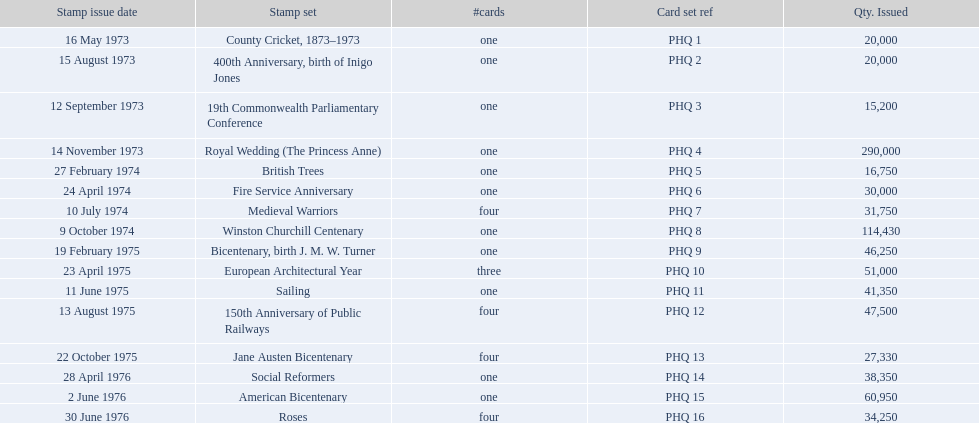Which year had the most stamps issued? 1973. Would you mind parsing the complete table? {'header': ['Stamp issue date', 'Stamp set', '#cards', 'Card set ref', 'Qty. Issued'], 'rows': [['16 May 1973', 'County Cricket, 1873–1973', 'one', 'PHQ 1', '20,000'], ['15 August 1973', '400th Anniversary, birth of Inigo Jones', 'one', 'PHQ 2', '20,000'], ['12 September 1973', '19th Commonwealth Parliamentary Conference', 'one', 'PHQ 3', '15,200'], ['14 November 1973', 'Royal Wedding (The Princess Anne)', 'one', 'PHQ 4', '290,000'], ['27 February 1974', 'British Trees', 'one', 'PHQ 5', '16,750'], ['24 April 1974', 'Fire Service Anniversary', 'one', 'PHQ 6', '30,000'], ['10 July 1974', 'Medieval Warriors', 'four', 'PHQ 7', '31,750'], ['9 October 1974', 'Winston Churchill Centenary', 'one', 'PHQ 8', '114,430'], ['19 February 1975', 'Bicentenary, birth J. M. W. Turner', 'one', 'PHQ 9', '46,250'], ['23 April 1975', 'European Architectural Year', 'three', 'PHQ 10', '51,000'], ['11 June 1975', 'Sailing', 'one', 'PHQ 11', '41,350'], ['13 August 1975', '150th Anniversary of Public Railways', 'four', 'PHQ 12', '47,500'], ['22 October 1975', 'Jane Austen Bicentenary', 'four', 'PHQ 13', '27,330'], ['28 April 1976', 'Social Reformers', 'one', 'PHQ 14', '38,350'], ['2 June 1976', 'American Bicentenary', 'one', 'PHQ 15', '60,950'], ['30 June 1976', 'Roses', 'four', 'PHQ 16', '34,250']]} 